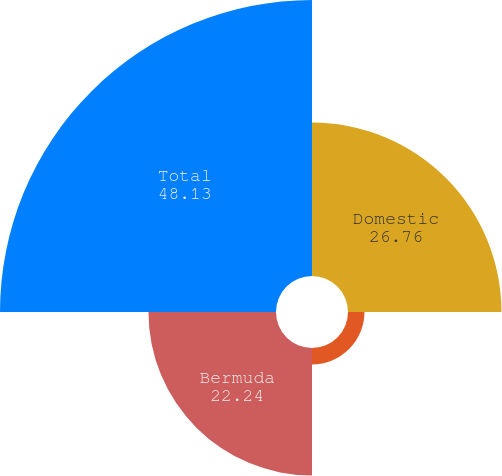Convert chart to OTSL. <chart><loc_0><loc_0><loc_500><loc_500><pie_chart><fcel>Domestic<fcel>International<fcel>Bermuda<fcel>Total<nl><fcel>26.76%<fcel>2.87%<fcel>22.24%<fcel>48.13%<nl></chart> 